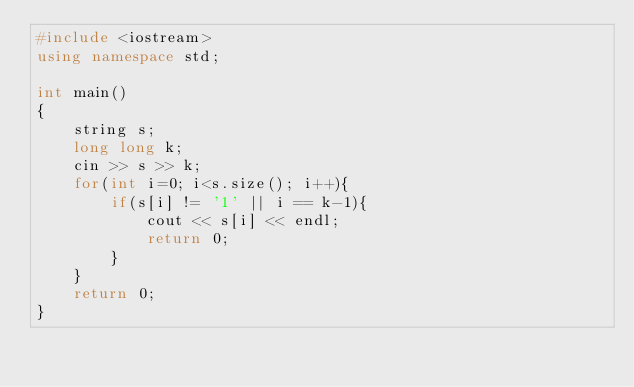<code> <loc_0><loc_0><loc_500><loc_500><_C++_>#include <iostream>
using namespace std;

int main()
{
    string s;
    long long k;
    cin >> s >> k;
    for(int i=0; i<s.size(); i++){
        if(s[i] != '1' || i == k-1){
            cout << s[i] << endl;
            return 0;
        }
    }
    return 0;
}
</code> 